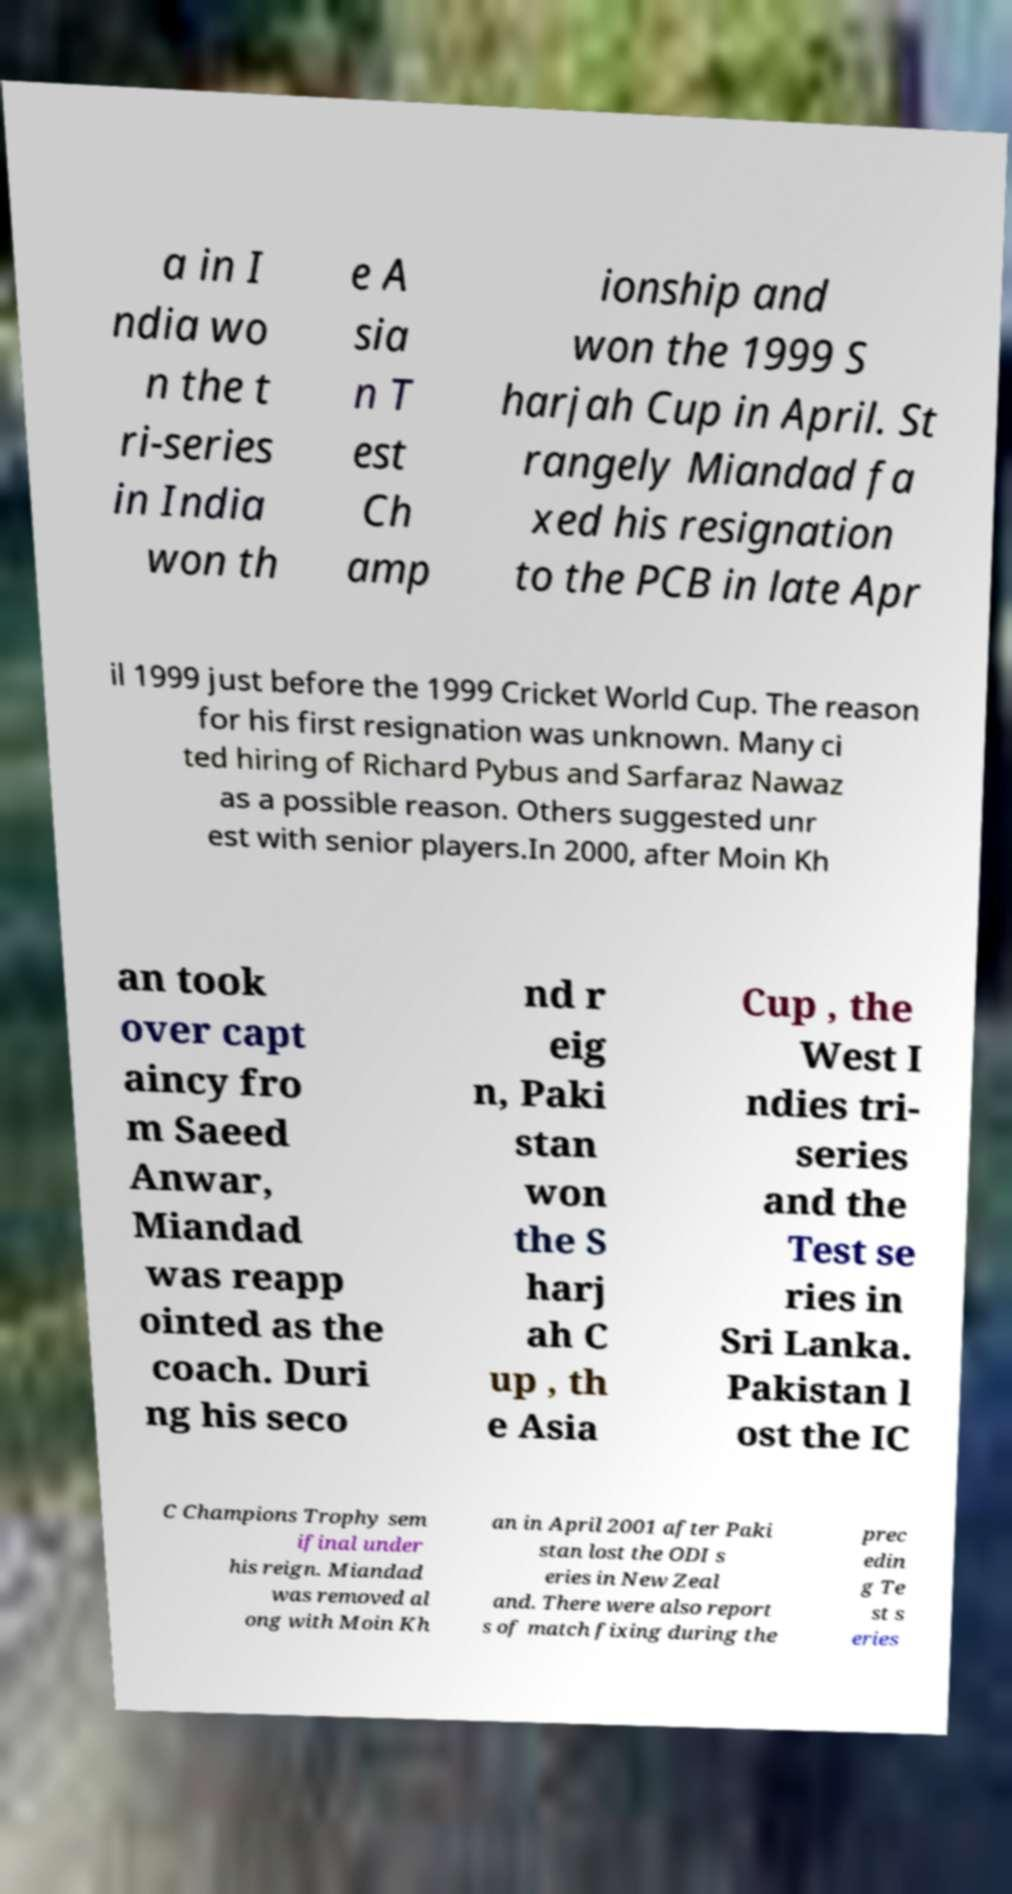I need the written content from this picture converted into text. Can you do that? a in I ndia wo n the t ri-series in India won th e A sia n T est Ch amp ionship and won the 1999 S harjah Cup in April. St rangely Miandad fa xed his resignation to the PCB in late Apr il 1999 just before the 1999 Cricket World Cup. The reason for his first resignation was unknown. Many ci ted hiring of Richard Pybus and Sarfaraz Nawaz as a possible reason. Others suggested unr est with senior players.In 2000, after Moin Kh an took over capt aincy fro m Saeed Anwar, Miandad was reapp ointed as the coach. Duri ng his seco nd r eig n, Paki stan won the S harj ah C up , th e Asia Cup , the West I ndies tri- series and the Test se ries in Sri Lanka. Pakistan l ost the IC C Champions Trophy sem ifinal under his reign. Miandad was removed al ong with Moin Kh an in April 2001 after Paki stan lost the ODI s eries in New Zeal and. There were also report s of match fixing during the prec edin g Te st s eries 